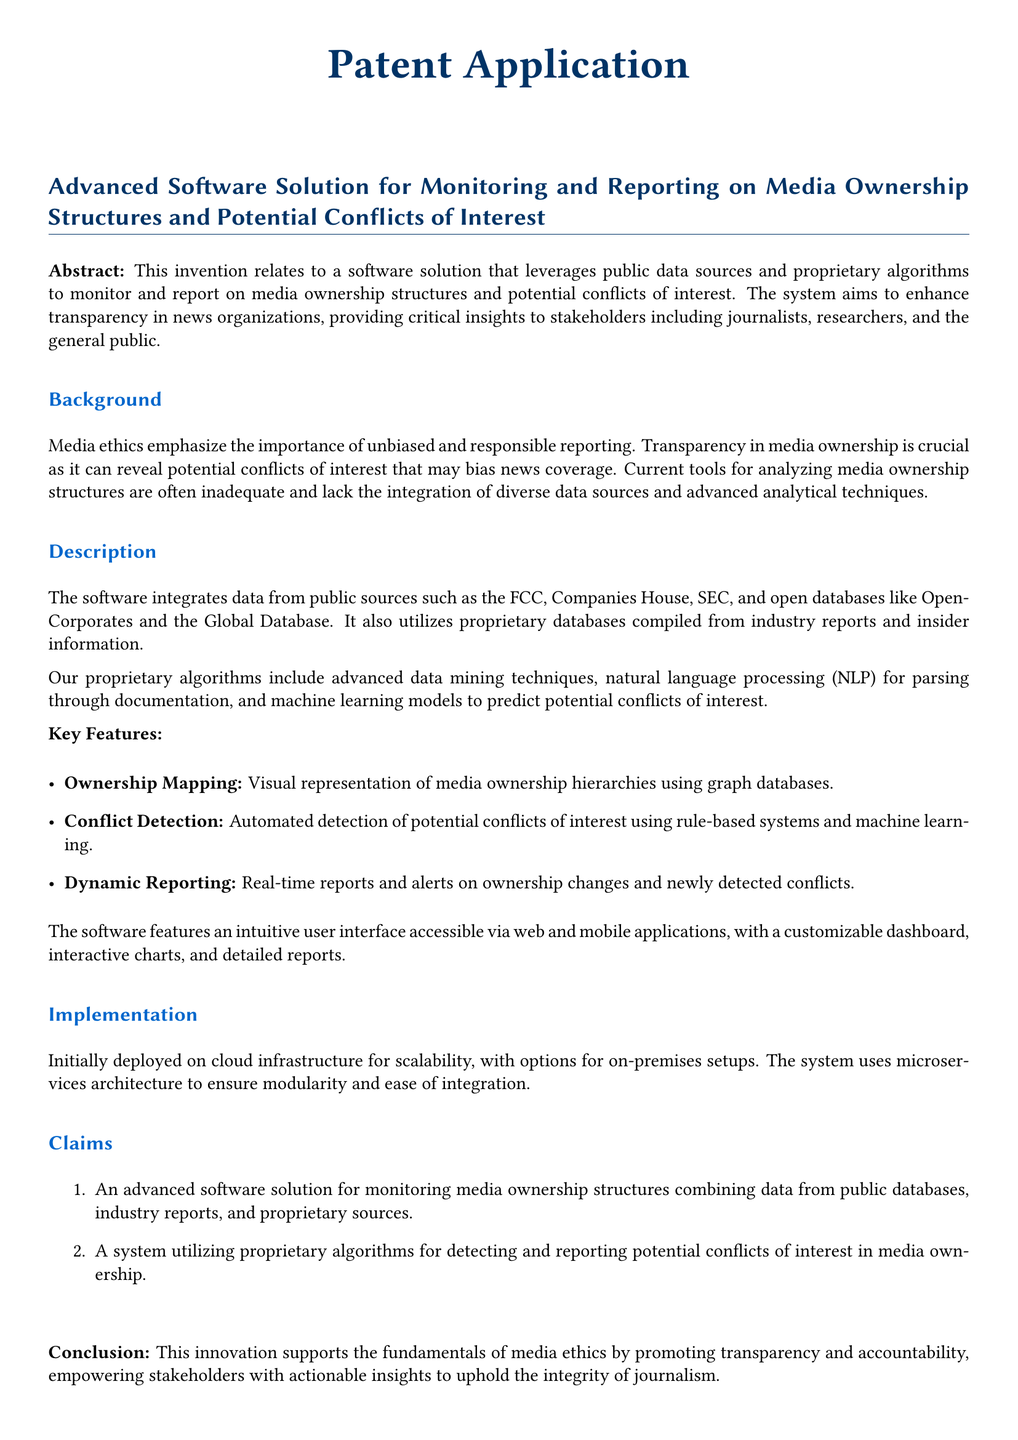What is the main purpose of the software solution? The main purpose of the software solution is to monitor and report on media ownership structures and potential conflicts of interest.
Answer: Monitor and report on media ownership structures and potential conflicts of interest What data sources does the software utilize? The software utilizes public data sources such as the FCC, Companies House, SEC, and open databases like OpenCorporates and the Global Database.
Answer: FCC, Companies House, SEC, OpenCorporates, Global Database What advanced techniques are mentioned in the software's proprietary algorithms? The advanced techniques mentioned include data mining, natural language processing (NLP), and machine learning models.
Answer: Data mining, natural language processing, machine learning models How does the software notify users of changes? The software provides real-time reports and alerts on ownership changes and newly detected conflicts.
Answer: Real-time reports and alerts What type of architecture does the system use? The system uses microservices architecture to ensure modularity and ease of integration.
Answer: Microservices architecture What is the target audience for the insights provided by the software? The target audience for the insights includes journalists, researchers, and the general public.
Answer: Journalists, researchers, general public What feature allows visual representation of media ownership? The feature that allows visual representation of media ownership is Ownership Mapping.
Answer: Ownership Mapping What is the deployment option mentioned for scalability? The deployment option mentioned for scalability is cloud infrastructure.
Answer: Cloud infrastructure 